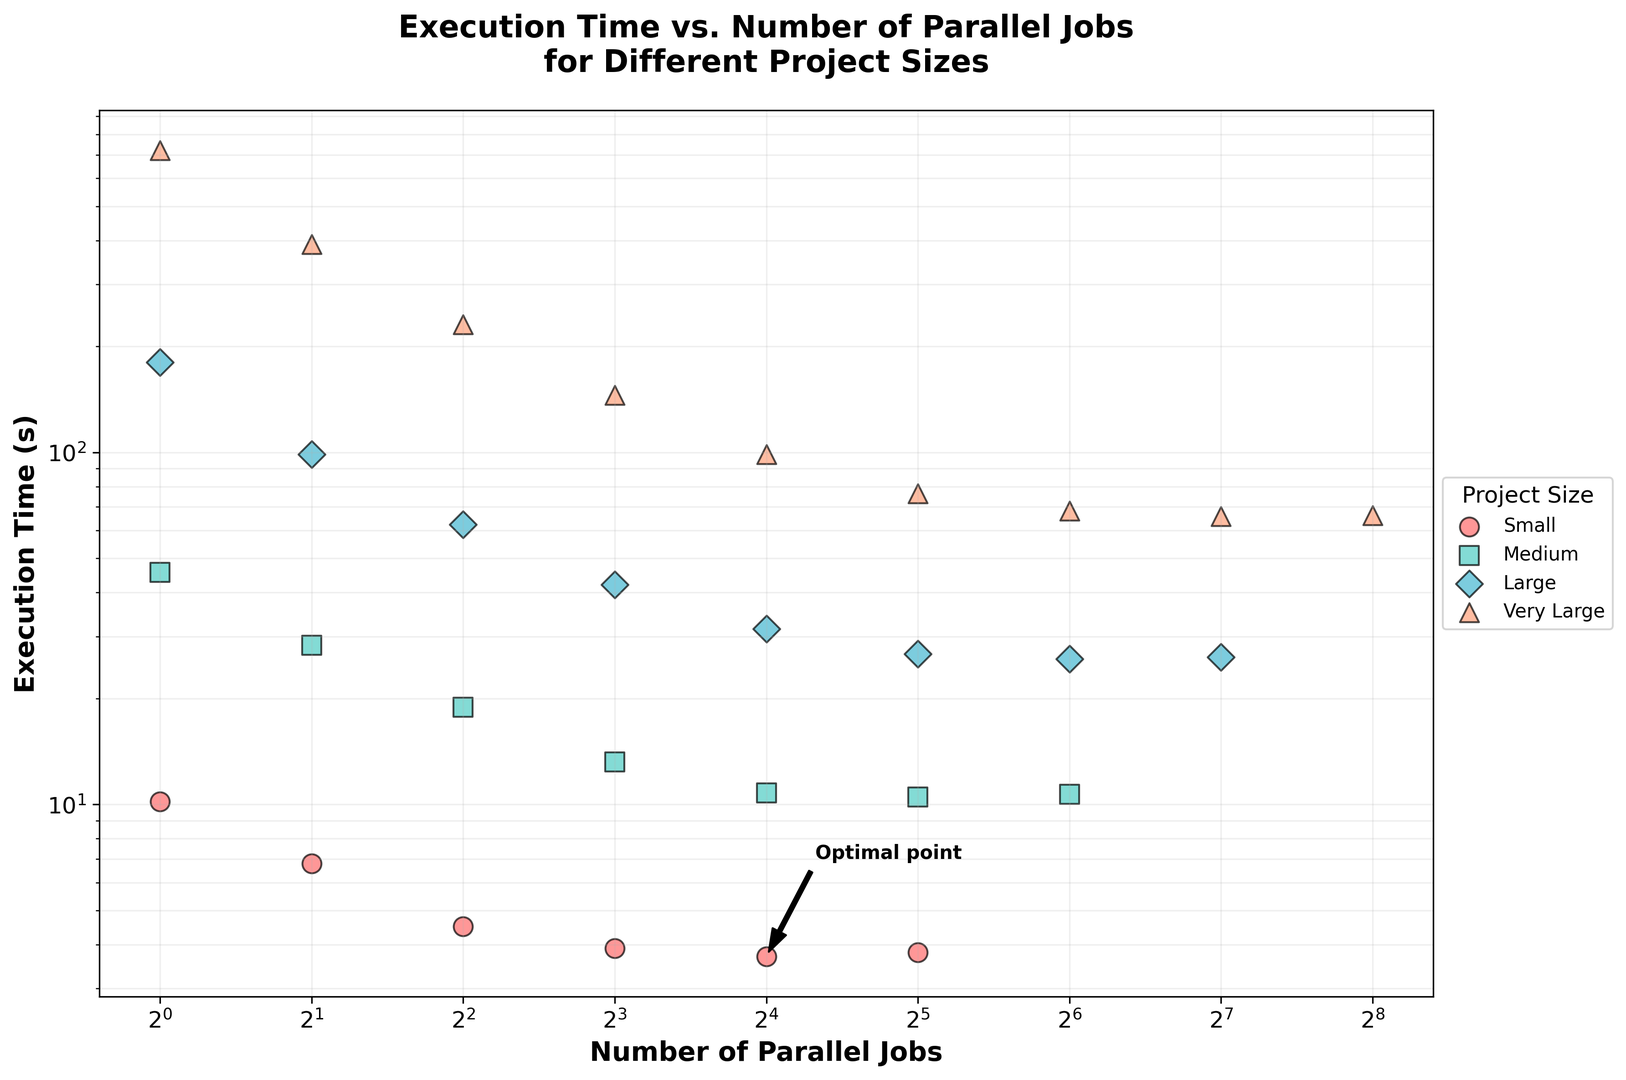How does the execution time for the 'small' project size change as the number of parallel jobs increases? For the 'small' project size, execution time steadily decreases as the number of parallel jobs increases from 1 to 16. At 32 jobs, the execution time slightly increases again.
Answer: Execution time generally decreases, with a slight increase at 32 jobs Which project size sees the greatest reduction in execution time from 1 to 128 parallel jobs? The 'very_large' project size sees the greatest reduction in execution time as the number of parallel jobs increases from 1 to 128, dropping from 720.6 seconds to 65.9 seconds.
Answer: Very Large Is there a point where the execution time stops improving significantly for the 'medium' project size as the number of parallel jobs increases? For the 'medium' project size, the execution time improves significantly up to 32 parallel jobs, after which further increases show minimal improvement.
Answer: At 32 jobs Compare the execution times for 'large' and 'very_large' project sizes with 64 parallel jobs. Which one is faster? For 64 parallel jobs, the 'large' project size has an execution time of 25.9 seconds, whereas the 'very_large' project size has an execution time of 68.2 seconds. Therefore, the 'large' project size is faster.
Answer: Large What happens to the execution time of a 'very_large' project size beyond 128 parallel jobs? Beyond 128 parallel jobs, the execution time of a 'very_large' project size shows a slight increase from 65.9 seconds to 66.3 seconds at 256 parallel jobs.
Answer: Slight increase Which project size has the optimal point annotated on the plot? The optimal point is annotated on the plot for the 'small' project size at 16 parallel jobs.
Answer: Small Does the execution time for 'medium' and 'large' projects converge at higher numbers of parallel jobs? If yes, at what execution time? The execution times for 'medium' and 'large' projects converge around higher numbers of parallel jobs. At 64 jobs, both have execution times very close, around 10.7 seconds for medium and 25.9 seconds for large.
Answer: No precise convergence point Are there any project sizes where the execution time increases significantly after a certain number of parallel jobs? Yes, in the 'small' project size, the execution time increases slightly after 32 parallel jobs, and the 'very_large' project size shows a slight increase after 64 parallel jobs. Significant changes are not apparent for 'medium' and 'large' sizes.
Answer: Small and Very Large What is the trend in execution time for the 'medium' project size from 1 to 16 parallel jobs? The execution time for the 'medium' project size continuously decreases from 45.6 seconds to 10.8 seconds as the number of parallel jobs increases from 1 to 16.
Answer: Decreasing trend Compare the smallest execution time for each project size. Which has the smallest execution time overall? The smallest execution times for 'small', 'medium', 'large', and 'very_large' project sizes are 3.7, 10.5, 25.9, and 65.9 seconds, respectively. The 'small' project size has the smallest execution time overall at 3.7 seconds.
Answer: Small 